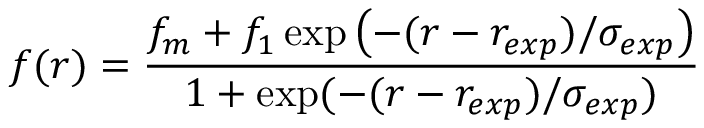Convert formula to latex. <formula><loc_0><loc_0><loc_500><loc_500>f ( r ) = \frac { f _ { m } + f _ { 1 } \exp \left ( - ( r - r _ { e x p } ) / \sigma _ { e x p } \right ) } { 1 + \exp ( - ( r - r _ { e x p } ) / \sigma _ { e x p } ) }</formula> 